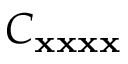<formula> <loc_0><loc_0><loc_500><loc_500>C _ { { x } { x } { x } { x } }</formula> 